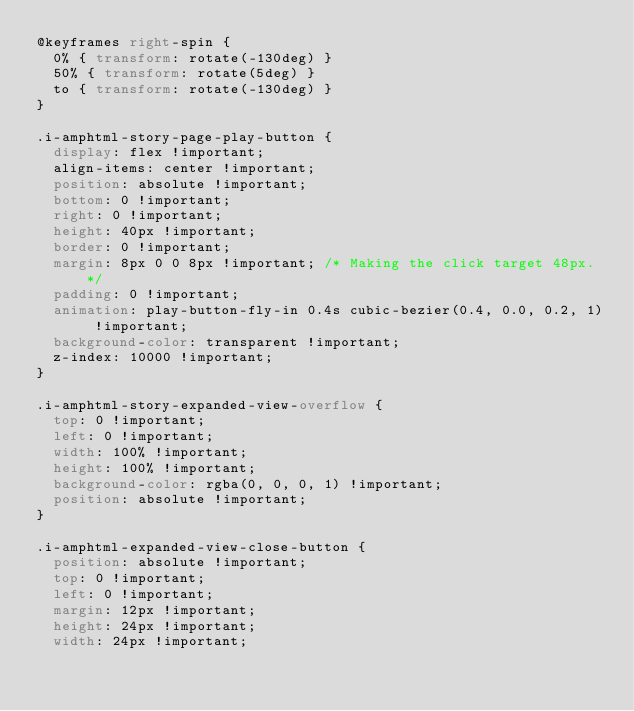<code> <loc_0><loc_0><loc_500><loc_500><_CSS_>@keyframes right-spin {
  0% { transform: rotate(-130deg) }
  50% { transform: rotate(5deg) }
  to { transform: rotate(-130deg) }
}

.i-amphtml-story-page-play-button {
  display: flex !important;
  align-items: center !important;
  position: absolute !important;
  bottom: 0 !important;
  right: 0 !important;
  height: 40px !important;
  border: 0 !important;
  margin: 8px 0 0 8px !important; /* Making the click target 48px.*/
  padding: 0 !important;
  animation: play-button-fly-in 0.4s cubic-bezier(0.4, 0.0, 0.2, 1) !important;
  background-color: transparent !important;
  z-index: 10000 !important;
}

.i-amphtml-story-expanded-view-overflow {
  top: 0 !important;
  left: 0 !important;
  width: 100% !important;
  height: 100% !important;
  background-color: rgba(0, 0, 0, 1) !important;
  position: absolute !important;
}

.i-amphtml-expanded-view-close-button {
  position: absolute !important;
  top: 0 !important;
  left: 0 !important;
  margin: 12px !important;
  height: 24px !important;
  width: 24px !important;</code> 